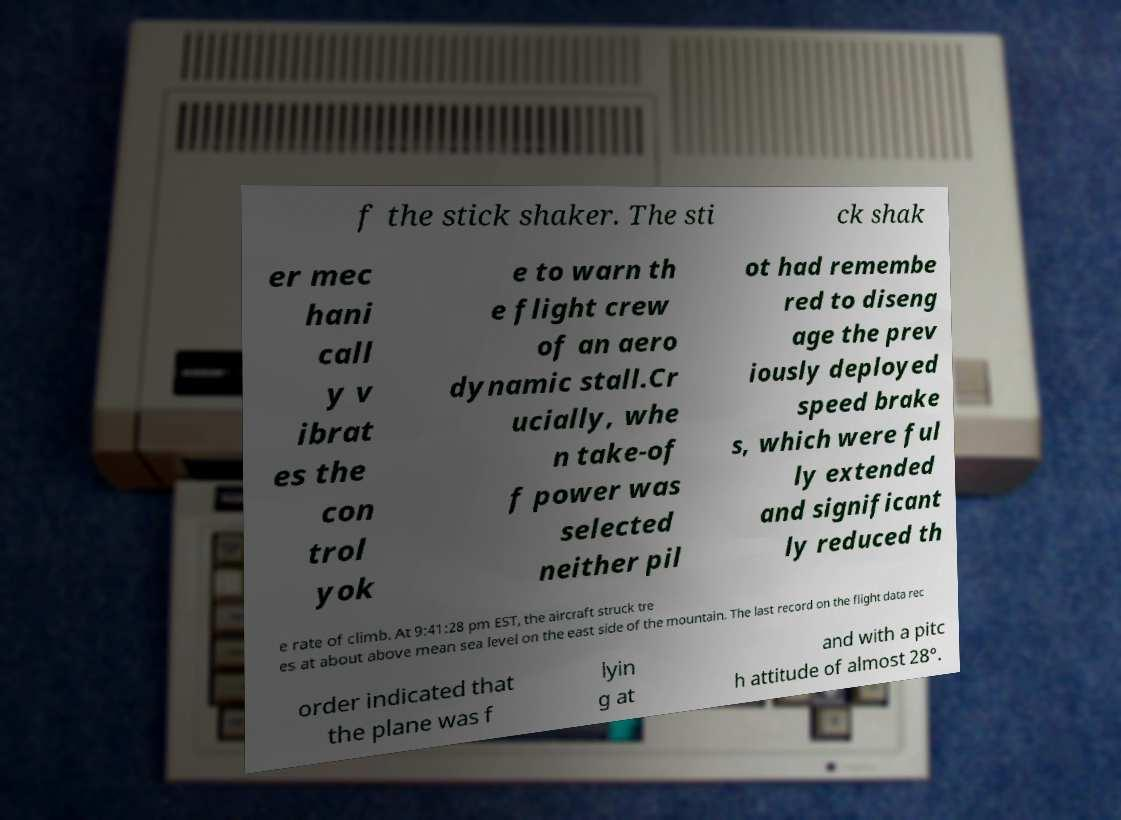Could you assist in decoding the text presented in this image and type it out clearly? f the stick shaker. The sti ck shak er mec hani call y v ibrat es the con trol yok e to warn th e flight crew of an aero dynamic stall.Cr ucially, whe n take-of f power was selected neither pil ot had remembe red to diseng age the prev iously deployed speed brake s, which were ful ly extended and significant ly reduced th e rate of climb. At 9:41:28 pm EST, the aircraft struck tre es at about above mean sea level on the east side of the mountain. The last record on the flight data rec order indicated that the plane was f lyin g at and with a pitc h attitude of almost 28°. 